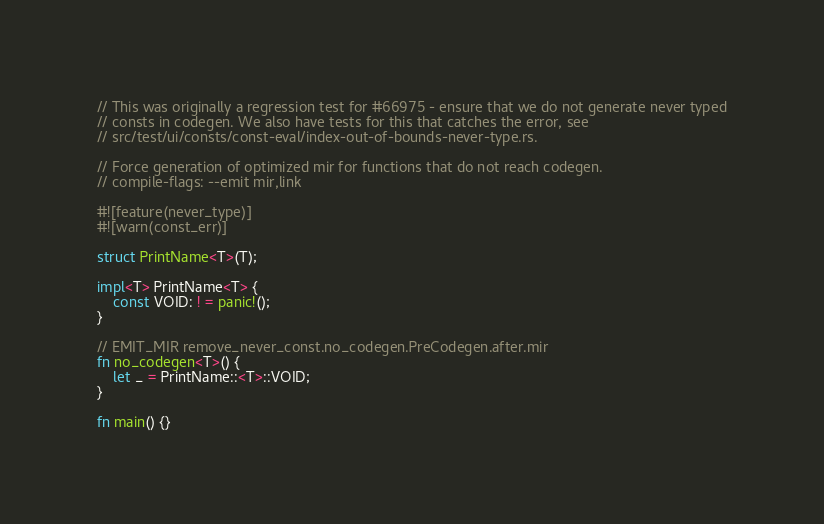Convert code to text. <code><loc_0><loc_0><loc_500><loc_500><_Rust_>// This was originally a regression test for #66975 - ensure that we do not generate never typed
// consts in codegen. We also have tests for this that catches the error, see
// src/test/ui/consts/const-eval/index-out-of-bounds-never-type.rs.

// Force generation of optimized mir for functions that do not reach codegen.
// compile-flags: --emit mir,link

#![feature(never_type)]
#![warn(const_err)]

struct PrintName<T>(T);

impl<T> PrintName<T> {
    const VOID: ! = panic!();
}

// EMIT_MIR remove_never_const.no_codegen.PreCodegen.after.mir
fn no_codegen<T>() {
    let _ = PrintName::<T>::VOID;
}

fn main() {}
</code> 